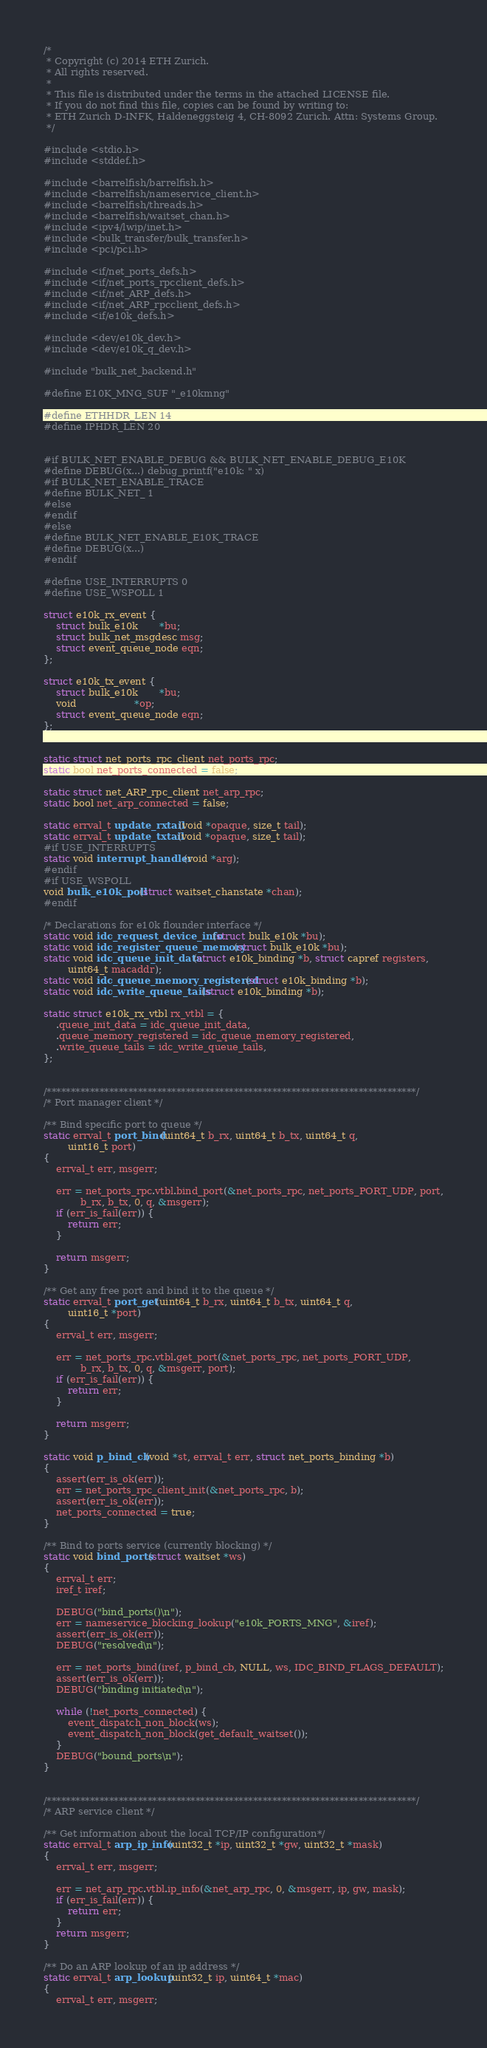Convert code to text. <code><loc_0><loc_0><loc_500><loc_500><_C_>/*
 * Copyright (c) 2014 ETH Zurich.
 * All rights reserved.
 *
 * This file is distributed under the terms in the attached LICENSE file.
 * If you do not find this file, copies can be found by writing to:
 * ETH Zurich D-INFK, Haldeneggsteig 4, CH-8092 Zurich. Attn: Systems Group.
 */

#include <stdio.h>
#include <stddef.h>

#include <barrelfish/barrelfish.h>
#include <barrelfish/nameservice_client.h>
#include <barrelfish/threads.h>
#include <barrelfish/waitset_chan.h>
#include <ipv4/lwip/inet.h>
#include <bulk_transfer/bulk_transfer.h>
#include <pci/pci.h>

#include <if/net_ports_defs.h>
#include <if/net_ports_rpcclient_defs.h>
#include <if/net_ARP_defs.h>
#include <if/net_ARP_rpcclient_defs.h>
#include <if/e10k_defs.h>

#include <dev/e10k_dev.h>
#include <dev/e10k_q_dev.h>

#include "bulk_net_backend.h"

#define E10K_MNG_SUF "_e10kmng"

#define ETHHDR_LEN 14
#define IPHDR_LEN 20


#if BULK_NET_ENABLE_DEBUG && BULK_NET_ENABLE_DEBUG_E10K
#define DEBUG(x...) debug_printf("e10k: " x)
#if BULK_NET_ENABLE_TRACE
#define BULK_NET_ 1
#else
#endif
#else
#define BULK_NET_ENABLE_E10K_TRACE
#define DEBUG(x...)
#endif

#define USE_INTERRUPTS 0
#define USE_WSPOLL 1

struct e10k_rx_event {
    struct bulk_e10k       *bu;
    struct bulk_net_msgdesc msg;
    struct event_queue_node eqn;
};

struct e10k_tx_event {
    struct bulk_e10k       *bu;
    void                   *op;
    struct event_queue_node eqn;
};


static struct net_ports_rpc_client net_ports_rpc;
static bool net_ports_connected = false;

static struct net_ARP_rpc_client net_arp_rpc;
static bool net_arp_connected = false;

static errval_t update_rxtail(void *opaque, size_t tail);
static errval_t update_txtail(void *opaque, size_t tail);
#if USE_INTERRUPTS
static void interrupt_handler(void *arg);
#endif
#if USE_WSPOLL
void bulk_e10k_poll(struct waitset_chanstate *chan);
#endif

/* Declarations for e10k flounder interface */
static void idc_request_device_info(struct bulk_e10k *bu);
static void idc_register_queue_memory(struct bulk_e10k *bu);
static void idc_queue_init_data(struct e10k_binding *b, struct capref registers,
        uint64_t macaddr);
static void idc_queue_memory_registered(struct e10k_binding *b);
static void idc_write_queue_tails(struct e10k_binding *b);

static struct e10k_rx_vtbl rx_vtbl = {
    .queue_init_data = idc_queue_init_data,
    .queue_memory_registered = idc_queue_memory_registered,
    .write_queue_tails = idc_write_queue_tails,
};


/*****************************************************************************/
/* Port manager client */

/** Bind specific port to queue */
static errval_t port_bind(uint64_t b_rx, uint64_t b_tx, uint64_t q,
        uint16_t port)
{
    errval_t err, msgerr;

    err = net_ports_rpc.vtbl.bind_port(&net_ports_rpc, net_ports_PORT_UDP, port,
            b_rx, b_tx, 0, q, &msgerr);
    if (err_is_fail(err)) {
        return err;
    }

    return msgerr;
}

/** Get any free port and bind it to the queue */
static errval_t port_get(uint64_t b_rx, uint64_t b_tx, uint64_t q,
        uint16_t *port)
{
    errval_t err, msgerr;

    err = net_ports_rpc.vtbl.get_port(&net_ports_rpc, net_ports_PORT_UDP,
            b_rx, b_tx, 0, q, &msgerr, port);
    if (err_is_fail(err)) {
        return err;
    }

    return msgerr;
}

static void p_bind_cb(void *st, errval_t err, struct net_ports_binding *b)
{
    assert(err_is_ok(err));
    err = net_ports_rpc_client_init(&net_ports_rpc, b);
    assert(err_is_ok(err));
    net_ports_connected = true;
}

/** Bind to ports service (currently blocking) */
static void bind_ports(struct waitset *ws)
{
    errval_t err;
    iref_t iref;

    DEBUG("bind_ports()\n");
    err = nameservice_blocking_lookup("e10k_PORTS_MNG", &iref);
    assert(err_is_ok(err));
    DEBUG("resolved\n");

    err = net_ports_bind(iref, p_bind_cb, NULL, ws, IDC_BIND_FLAGS_DEFAULT);
    assert(err_is_ok(err));
    DEBUG("binding initiated\n");

    while (!net_ports_connected) {
        event_dispatch_non_block(ws);
        event_dispatch_non_block(get_default_waitset());
    }
    DEBUG("bound_ports\n");
}


/*****************************************************************************/
/* ARP service client */

/** Get information about the local TCP/IP configuration*/
static errval_t arp_ip_info(uint32_t *ip, uint32_t *gw, uint32_t *mask)
{
    errval_t err, msgerr;

    err = net_arp_rpc.vtbl.ip_info(&net_arp_rpc, 0, &msgerr, ip, gw, mask);
    if (err_is_fail(err)) {
        return err;
    }
    return msgerr;
}

/** Do an ARP lookup of an ip address */
static errval_t arp_lookup(uint32_t ip, uint64_t *mac)
{
    errval_t err, msgerr;
</code> 